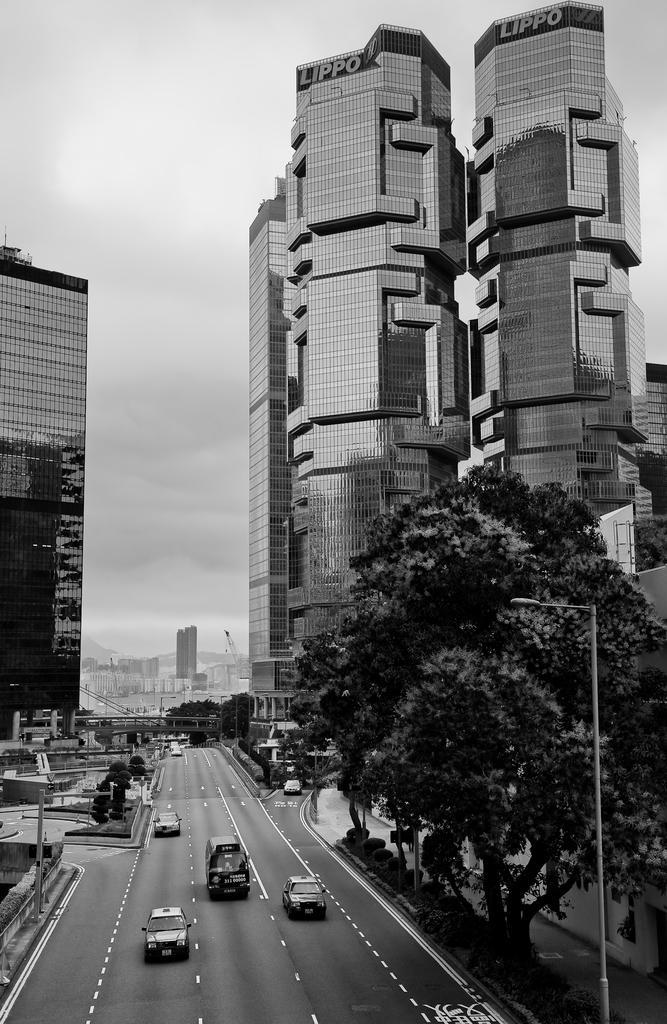Describe this image in one or two sentences. This is a black and white image. In this image we can see the road with some vehicles. We can also see some buildings, trees, plants and some street poles. On the backside we can see the sky which looks cloudy. 